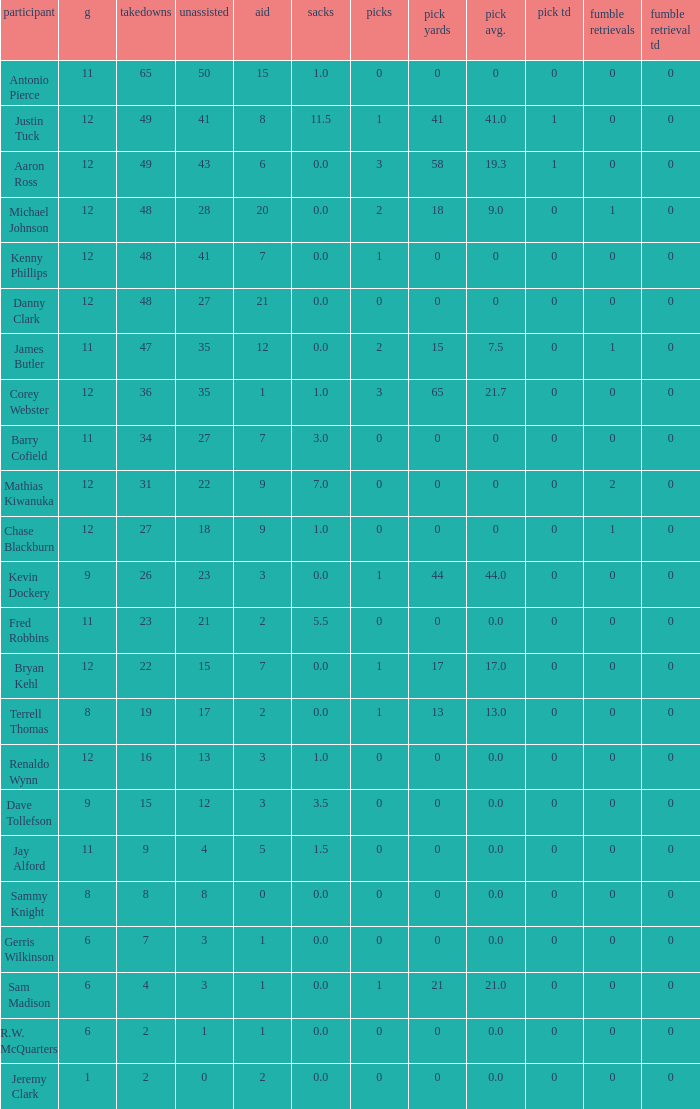5? 41.0. 